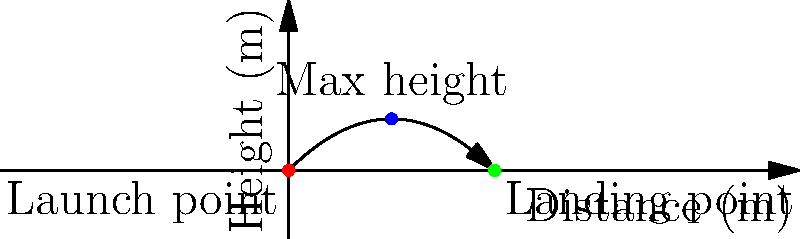As a soccer player, you're practicing your kicks. You kick a soccer ball with an initial velocity of 20 m/s at a 45-degree angle to the horizontal. Assuming no air resistance, calculate:

a) The maximum height reached by the ball
b) The total distance traveled horizontally
c) The time taken for the ball to return to the ground

Round your answers to two decimal places. Let's approach this step-by-step using the equations of motion for projectile motion:

1) First, let's define our variables:
   $v_0 = 20$ m/s (initial velocity)
   $\theta = 45°$ (angle)
   $g = 9.8$ m/s² (acceleration due to gravity)

2) We need to find the vertical and horizontal components of the initial velocity:
   $v_{0x} = v_0 \cos{\theta} = 20 \cos{45°} = 20 \cdot \frac{\sqrt{2}}{2} = 10\sqrt{2}$ m/s
   $v_{0y} = v_0 \sin{\theta} = 20 \sin{45°} = 20 \cdot \frac{\sqrt{2}}{2} = 10\sqrt{2}$ m/s

3) For the maximum height (a):
   At the highest point, vertical velocity is zero.
   $v_y = v_{0y} - gt = 0$
   $t = \frac{v_{0y}}{g} = \frac{10\sqrt{2}}{9.8} = 1.44$ s (time to reach max height)
   
   Maximum height: $h = v_{0y}t - \frac{1}{2}gt^2 = 10\sqrt{2} \cdot 1.44 - \frac{1}{2} \cdot 9.8 \cdot 1.44^2 = 10.20$ m

4) For the total horizontal distance (b):
   Time of flight is twice the time to reach max height: $t_{total} = 2 \cdot 1.44 = 2.88$ s
   Horizontal distance: $d = v_{0x} \cdot t_{total} = 10\sqrt{2} \cdot 2.88 = 40.81$ m

5) The time taken to return to the ground (c) is the total time of flight, which we calculated as 2.88 s.
Answer: a) 10.20 m
b) 40.81 m
c) 2.88 s 